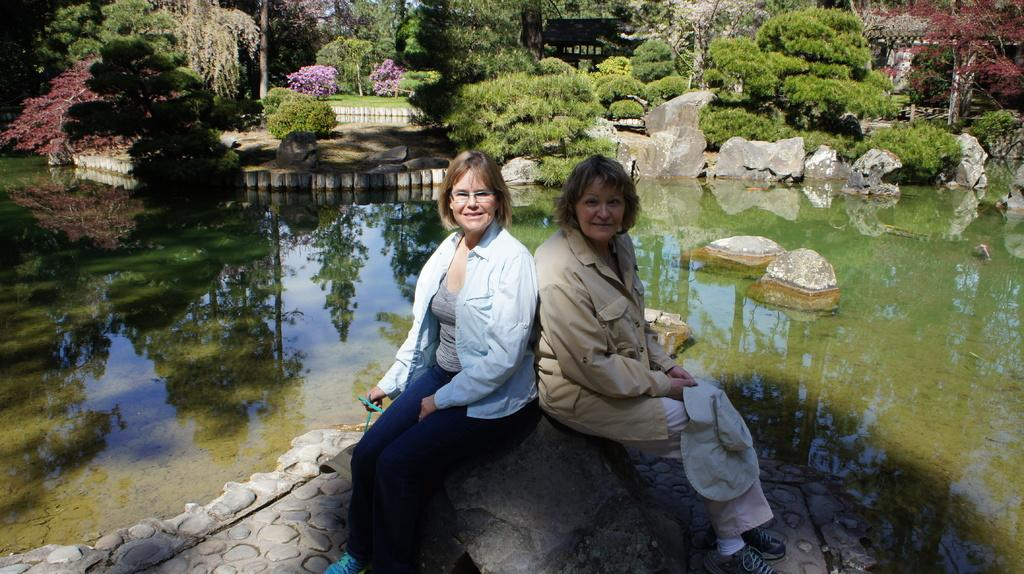How many women are in the image? There are two women in the image. What are the women doing in the image? The women are sitting and smiling in the image. What natural elements can be seen in the image? Water, rocks, trees, and bushes are visible in the image. What is the color of the water in the image? The water appears green in color. What type of veil can be seen on the kitty in the image? There is no kitty or veil present in the image. 